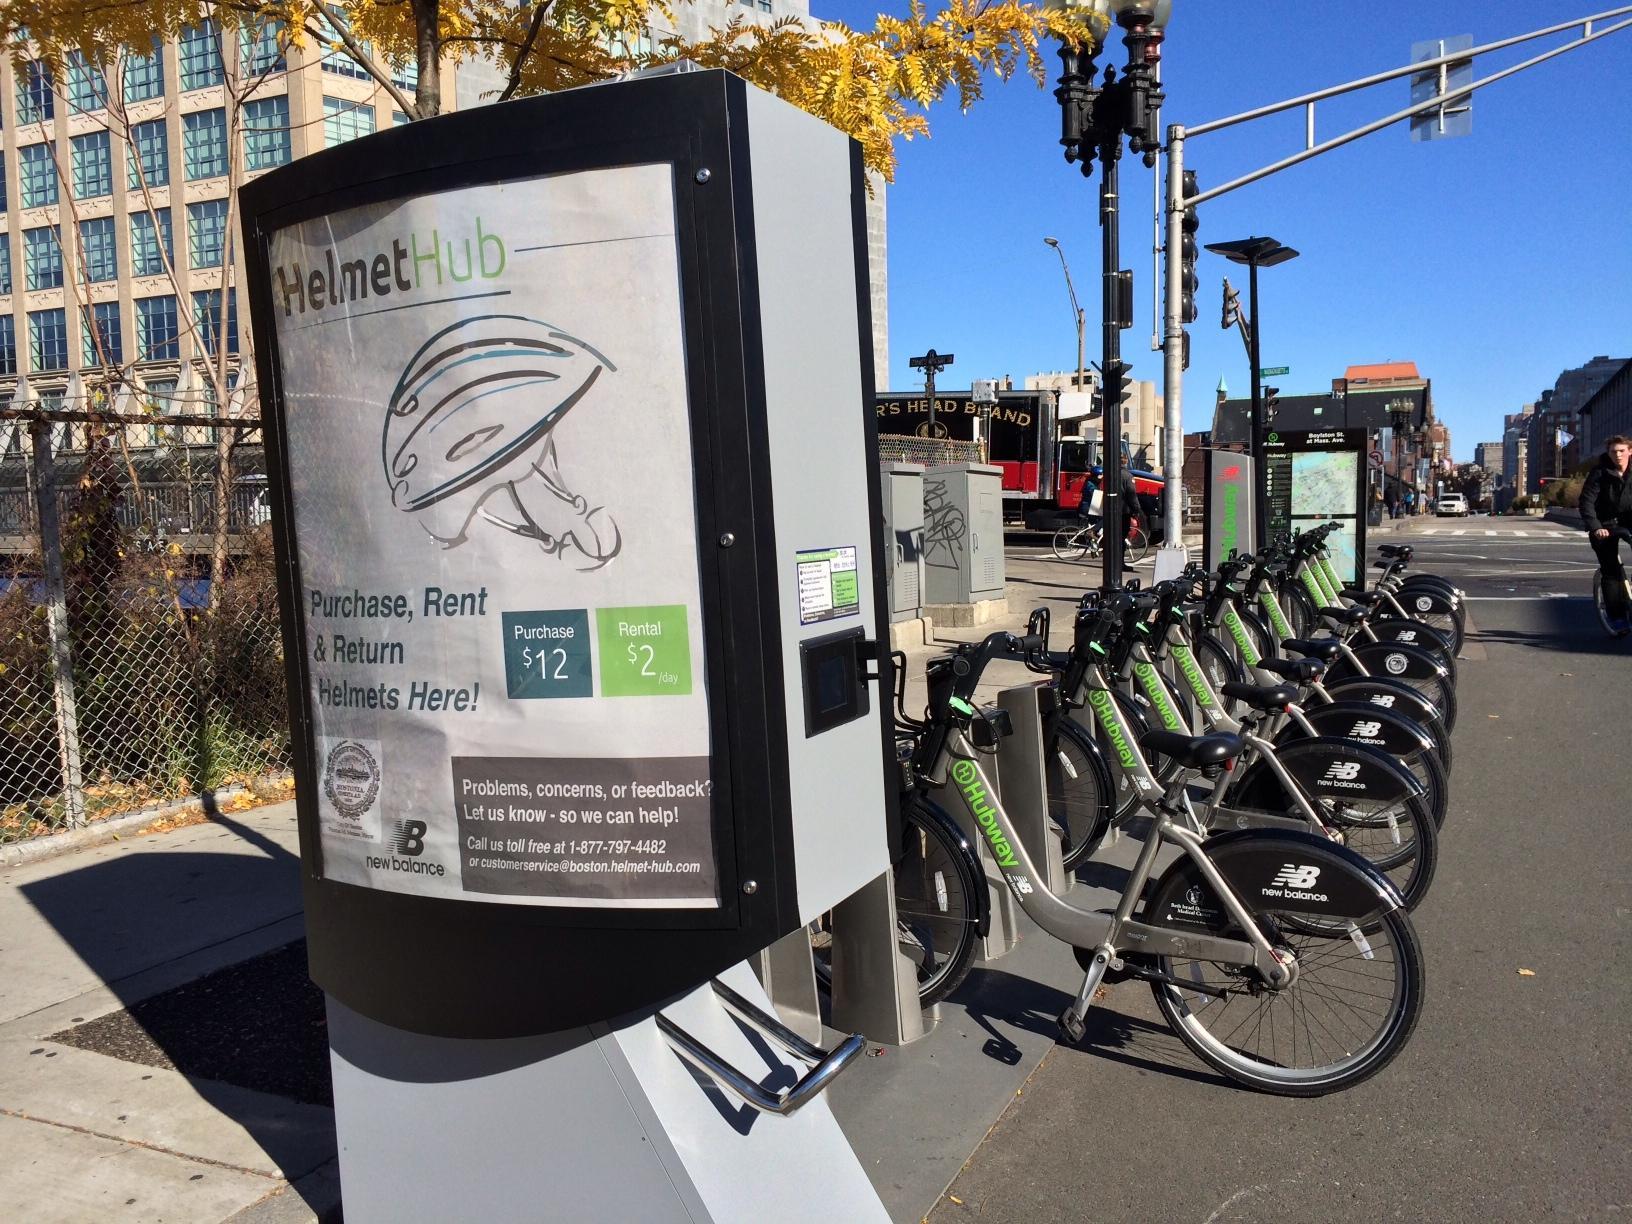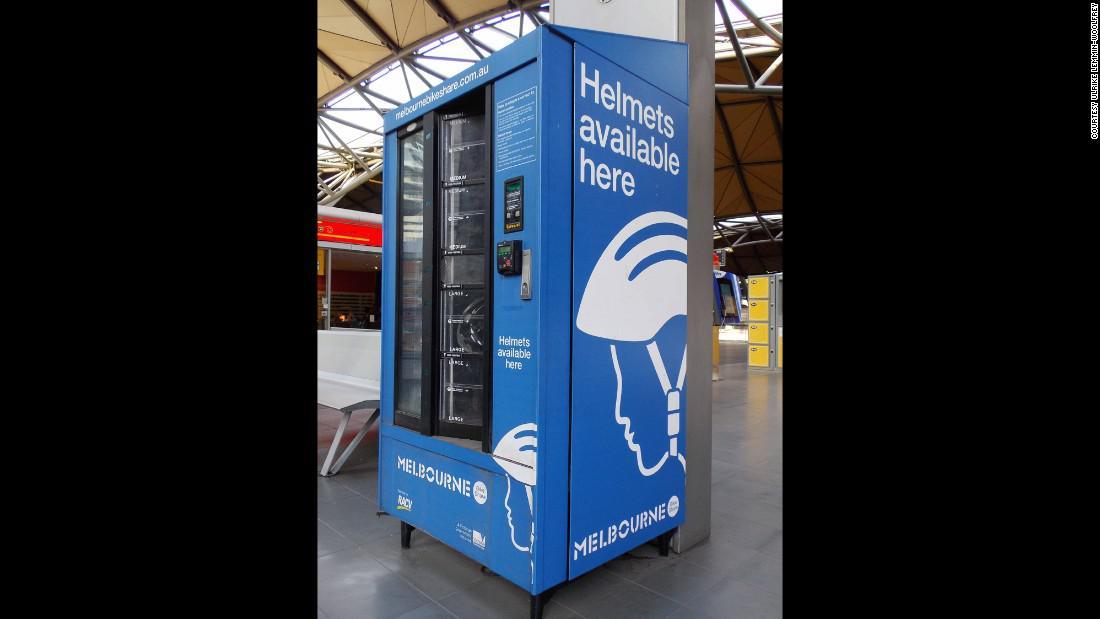The first image is the image on the left, the second image is the image on the right. Given the left and right images, does the statement "There is a at least one person in the image on the left." hold true? Answer yes or no. Yes. 